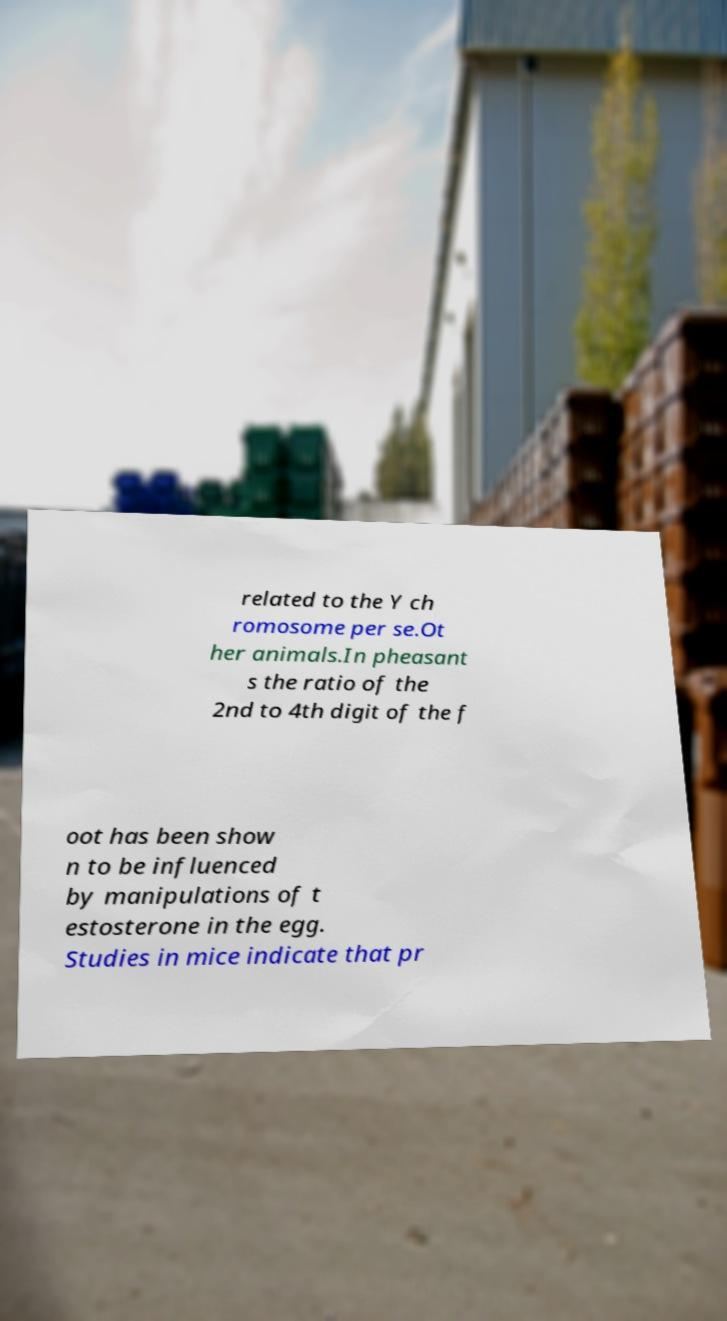Can you read and provide the text displayed in the image?This photo seems to have some interesting text. Can you extract and type it out for me? related to the Y ch romosome per se.Ot her animals.In pheasant s the ratio of the 2nd to 4th digit of the f oot has been show n to be influenced by manipulations of t estosterone in the egg. Studies in mice indicate that pr 